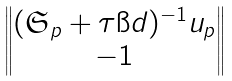Convert formula to latex. <formula><loc_0><loc_0><loc_500><loc_500>\begin{Vmatrix} ( \mathfrak { S } _ { p } + \tau \i d ) ^ { - 1 } u _ { p } \\ - 1 \end{Vmatrix}</formula> 